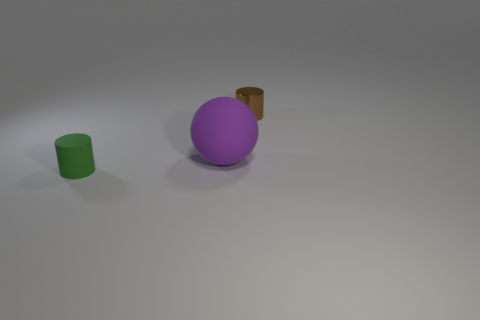Is there anything else that has the same size as the purple rubber sphere?
Your answer should be compact. No. Is the number of purple spheres in front of the green rubber thing the same as the number of purple rubber spheres that are to the right of the purple rubber ball?
Offer a terse response. Yes. How many small purple balls have the same material as the big object?
Keep it short and to the point. 0. What size is the rubber object to the right of the tiny cylinder in front of the tiny brown shiny thing?
Offer a very short reply. Large. There is a small object that is on the right side of the green thing; does it have the same shape as the small object that is in front of the brown cylinder?
Your response must be concise. Yes. Are there the same number of small metallic cylinders on the right side of the tiny brown cylinder and gray rubber cylinders?
Provide a succinct answer. Yes. There is a shiny thing that is the same shape as the tiny green matte object; what is its color?
Keep it short and to the point. Brown. Is the cylinder that is to the left of the brown thing made of the same material as the tiny brown object?
Give a very brief answer. No. What number of tiny things are either purple matte things or cyan things?
Offer a very short reply. 0. What size is the purple object?
Offer a very short reply. Large. 